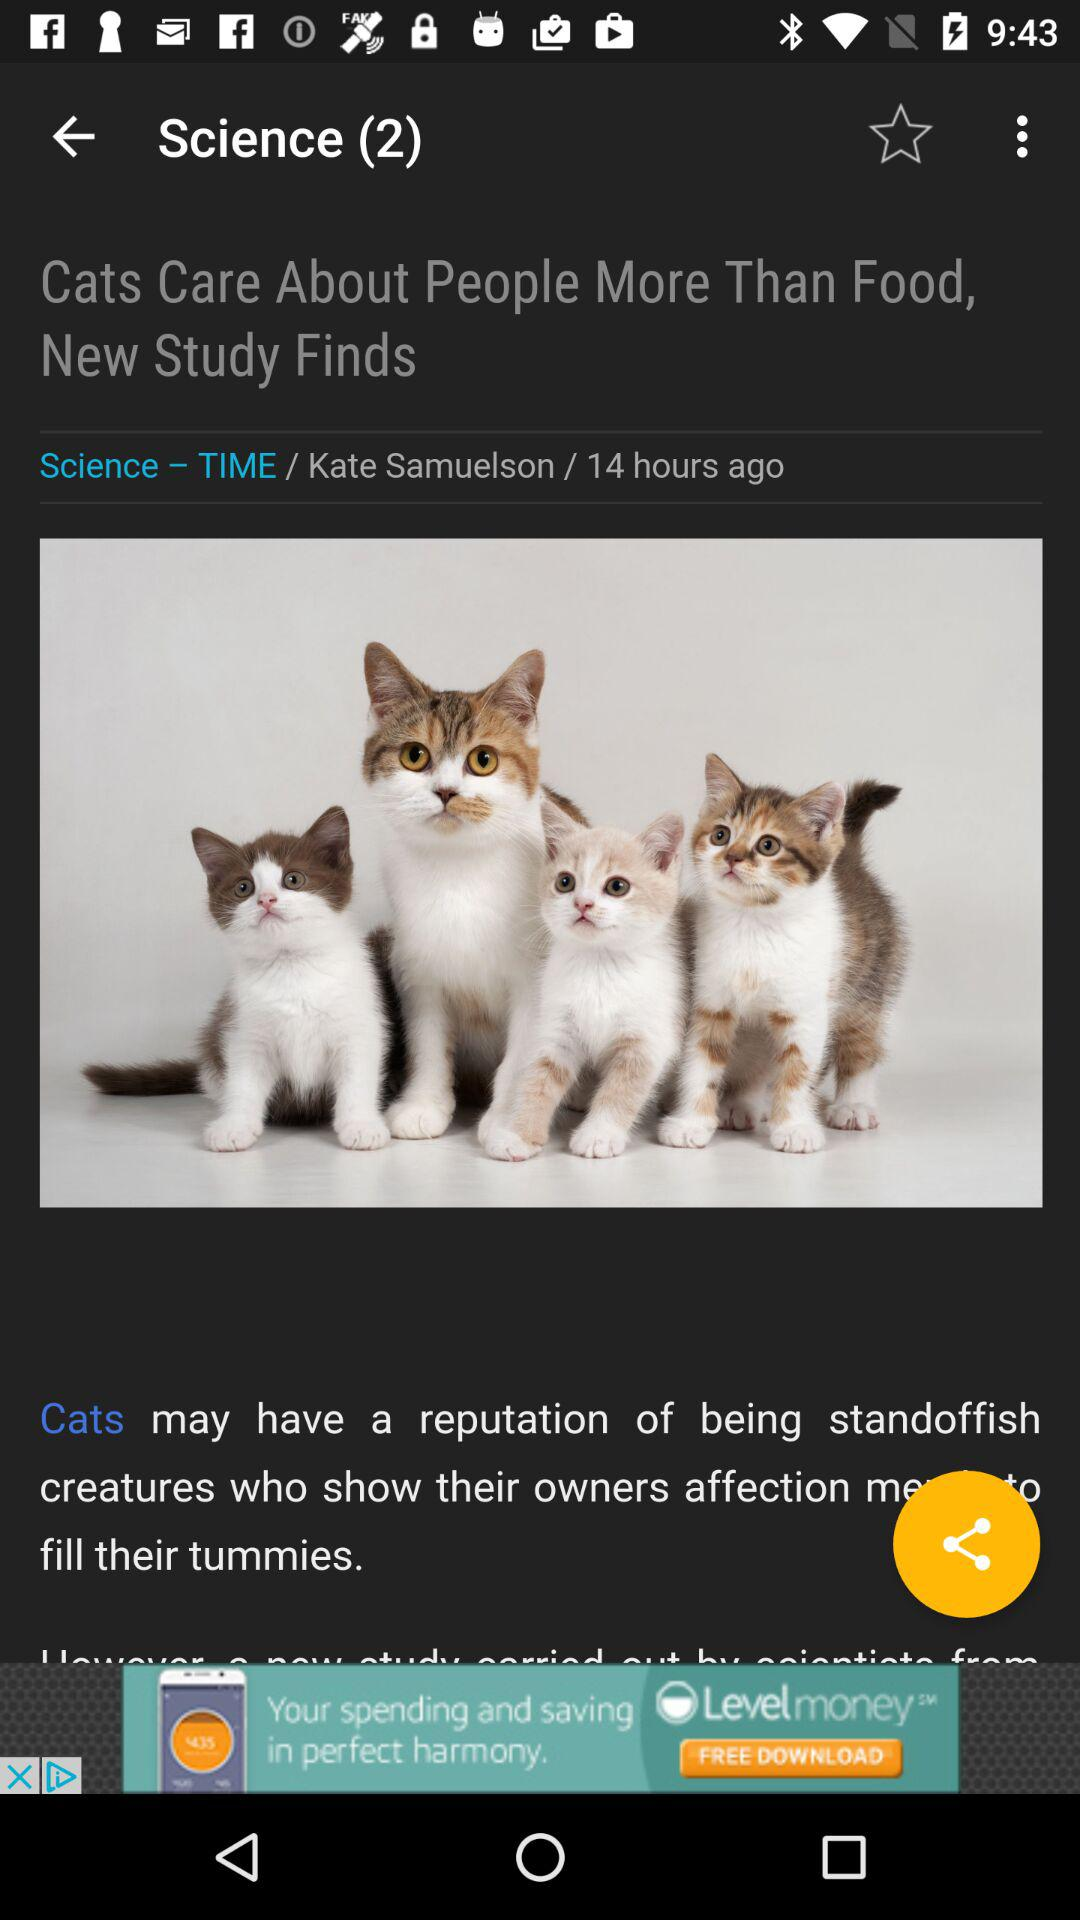What is the headline of the content? The headline is "Cats Care About People More Than Food, New Study Finds". 